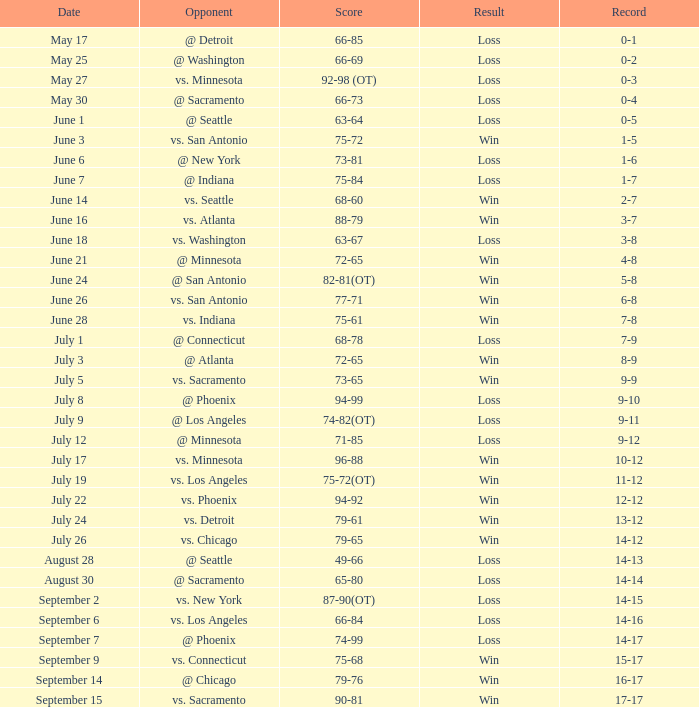What was the conclusion on may 30? Loss. 